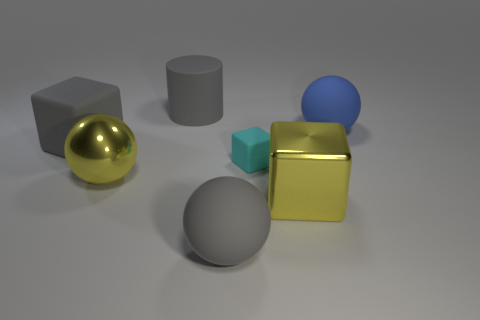There is a big object that is the same color as the shiny sphere; what shape is it?
Keep it short and to the point. Cube. What is the shape of the blue rubber object that is the same size as the gray rubber sphere?
Your response must be concise. Sphere. There is a big block that is the same color as the big cylinder; what is its material?
Offer a very short reply. Rubber. There is a yellow shiny sphere; are there any big yellow cubes in front of it?
Offer a very short reply. Yes. Are there any big yellow metallic things that have the same shape as the tiny cyan object?
Make the answer very short. Yes. Does the shiny object that is to the left of the small cyan matte block have the same shape as the big gray matte object in front of the large yellow sphere?
Make the answer very short. Yes. Are there any other cubes of the same size as the gray block?
Offer a terse response. Yes. Are there the same number of tiny rubber objects that are on the left side of the cyan matte cube and gray rubber things in front of the big cylinder?
Give a very brief answer. No. Are the yellow thing on the right side of the cyan rubber block and the ball that is to the left of the large gray cylinder made of the same material?
Keep it short and to the point. Yes. What material is the yellow cube?
Your response must be concise. Metal. 